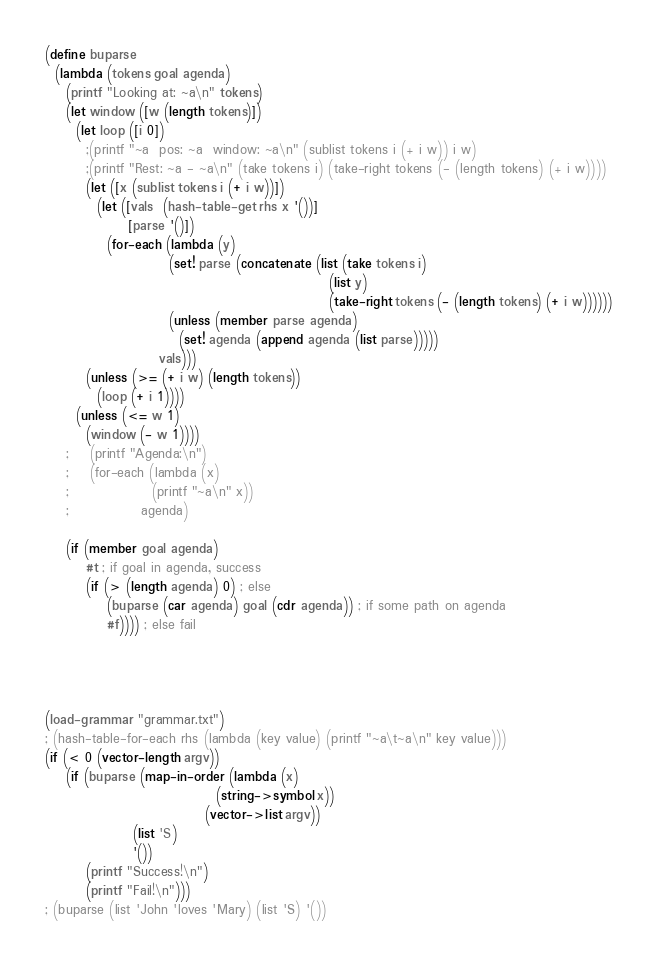<code> <loc_0><loc_0><loc_500><loc_500><_Scheme_>
(define buparse
  (lambda (tokens goal agenda)
    (printf "Looking at: ~a\n" tokens)
    (let window ([w (length tokens)])
      (let loop ([i 0])
        ;(printf "~a  pos: ~a  window: ~a\n" (sublist tokens i (+ i w)) i w)
        ;(printf "Rest: ~a - ~a\n" (take tokens i) (take-right tokens (- (length tokens) (+ i w))))
        (let ([x (sublist tokens i (+ i w))])
          (let ([vals  (hash-table-get rhs x '())]
                [parse '()])
            (for-each (lambda (y)
                        (set! parse (concatenate (list (take tokens i)
                                                       (list y)
                                                       (take-right tokens (- (length tokens) (+ i w))))))
                        (unless (member parse agenda)
                          (set! agenda (append agenda (list parse)))))
                      vals)))
        (unless (>= (+ i w) (length tokens))
          (loop (+ i 1))))
      (unless (<= w 1)
        (window (- w 1))))
    ;    (printf "Agenda:\n")
    ;    (for-each (lambda (x)
    ;                (printf "~a\n" x))
    ;              agenda)
    
    (if (member goal agenda)
        #t ; if goal in agenda, success
        (if (> (length agenda) 0) ; else
            (buparse (car agenda) goal (cdr agenda)) ; if some path on agenda
            #f)))) ; else fail




(load-grammar "grammar.txt")
; (hash-table-for-each rhs (lambda (key value) (printf "~a\t~a\n" key value)))
(if (< 0 (vector-length argv))
    (if (buparse (map-in-order (lambda (x)
                                 (string->symbol x))
                               (vector->list argv))
                 (list 'S)
                 '())
        (printf "Success!\n")
        (printf "Fail!\n")))
; (buparse (list 'John 'loves 'Mary) (list 'S) '())



</code> 